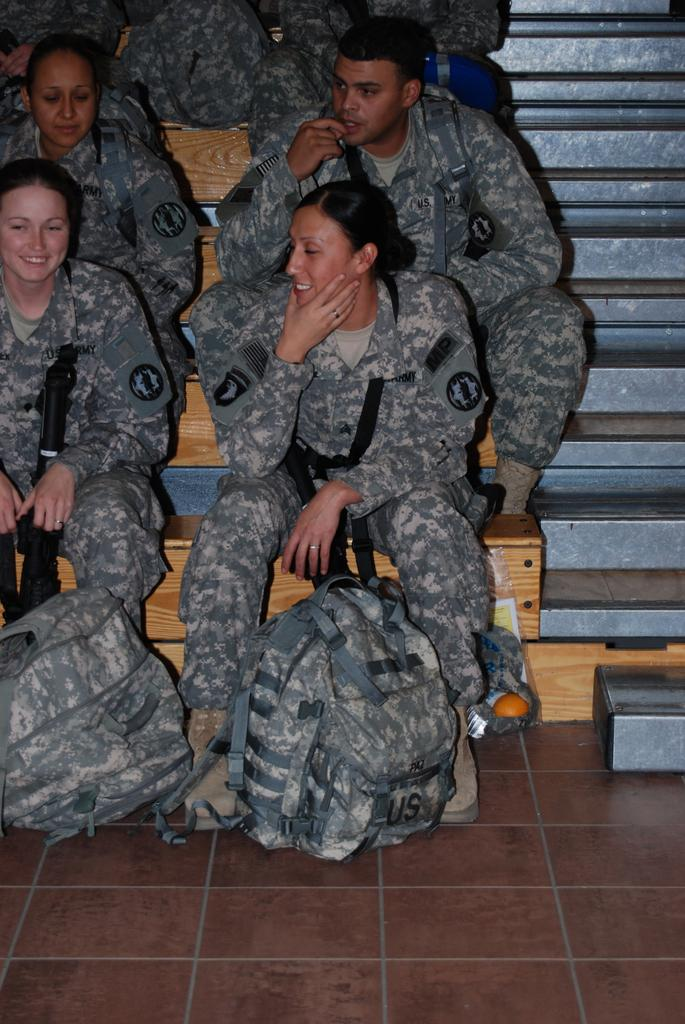What are the persons in the image doing? The persons in the image are sitting on the steps. Can you describe the expressions of the persons in the image? Two persons are smiling in the image. What items can be seen at the bottom of the image? There are two backpacks visible in the bottom of the image. What type of hall can be seen in the background of the image? There is no hall visible in the background of the image. What kind of wheel is attached to the backpacks in the image? There are no wheels attached to the backpacks in the image. 